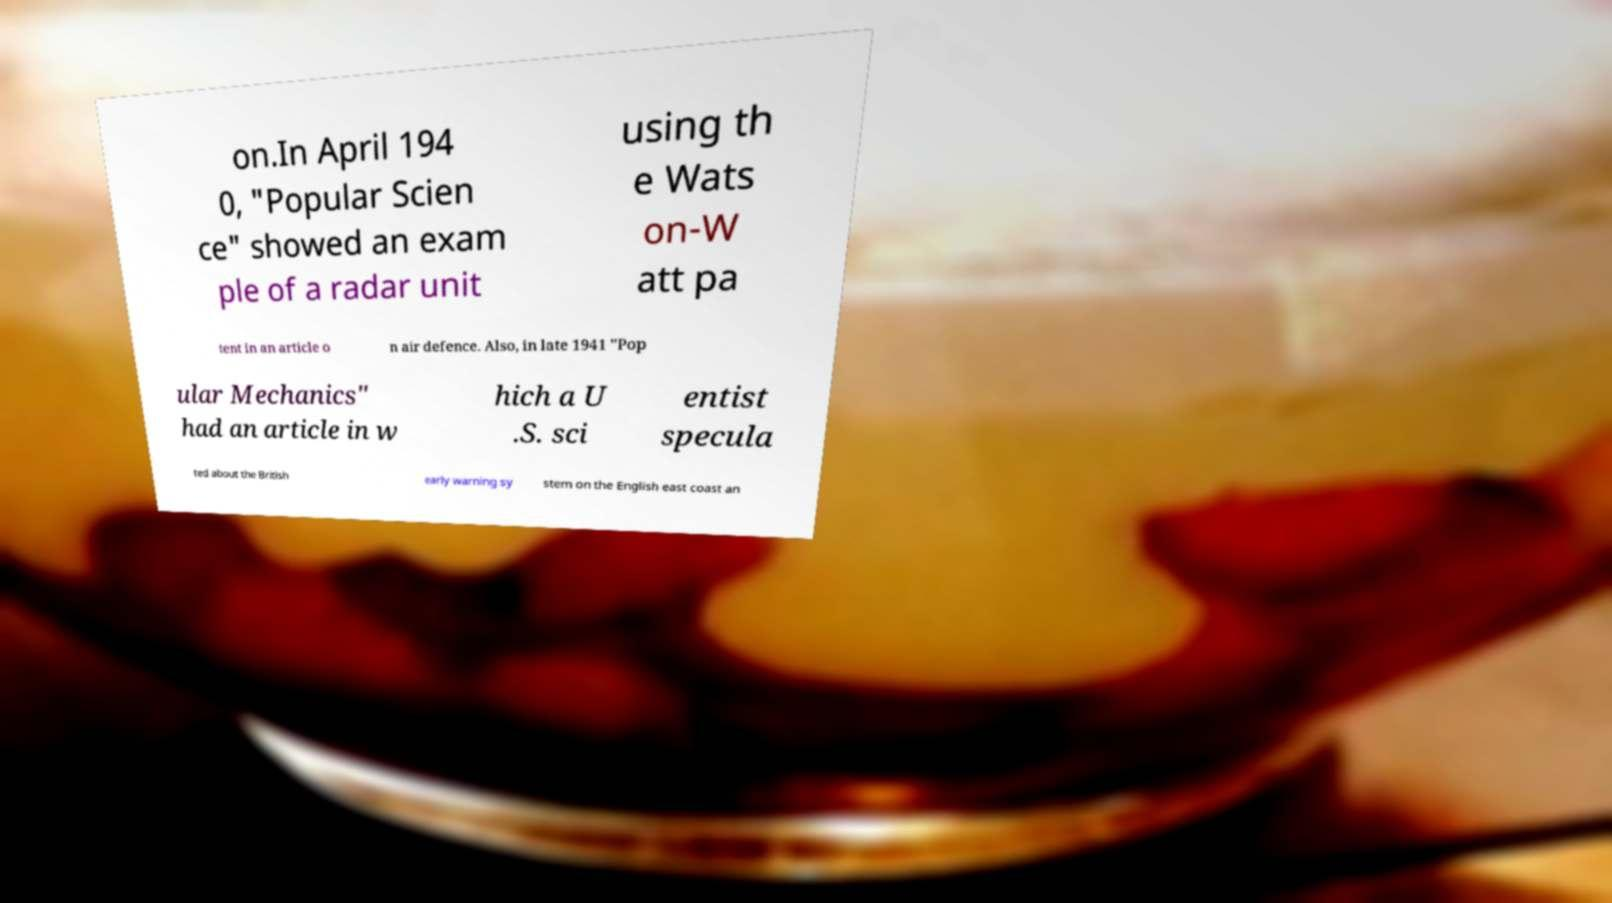Could you assist in decoding the text presented in this image and type it out clearly? on.In April 194 0, "Popular Scien ce" showed an exam ple of a radar unit using th e Wats on-W att pa tent in an article o n air defence. Also, in late 1941 "Pop ular Mechanics" had an article in w hich a U .S. sci entist specula ted about the British early warning sy stem on the English east coast an 